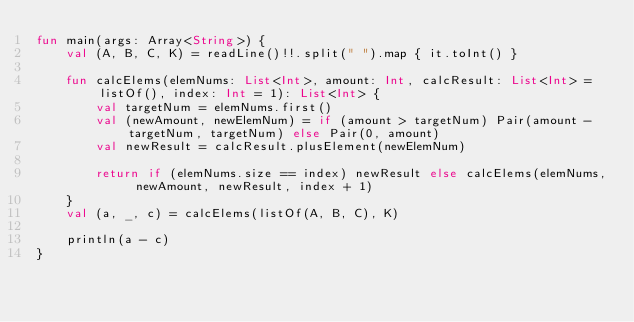Convert code to text. <code><loc_0><loc_0><loc_500><loc_500><_Kotlin_>fun main(args: Array<String>) {
    val (A, B, C, K) = readLine()!!.split(" ").map { it.toInt() }

    fun calcElems(elemNums: List<Int>, amount: Int, calcResult: List<Int> = listOf(), index: Int = 1): List<Int> {
        val targetNum = elemNums.first()
        val (newAmount, newElemNum) = if (amount > targetNum) Pair(amount - targetNum, targetNum) else Pair(0, amount)
        val newResult = calcResult.plusElement(newElemNum)

        return if (elemNums.size == index) newResult else calcElems(elemNums, newAmount, newResult, index + 1)
    }
    val (a, _, c) = calcElems(listOf(A, B, C), K)

    println(a - c)
}

</code> 